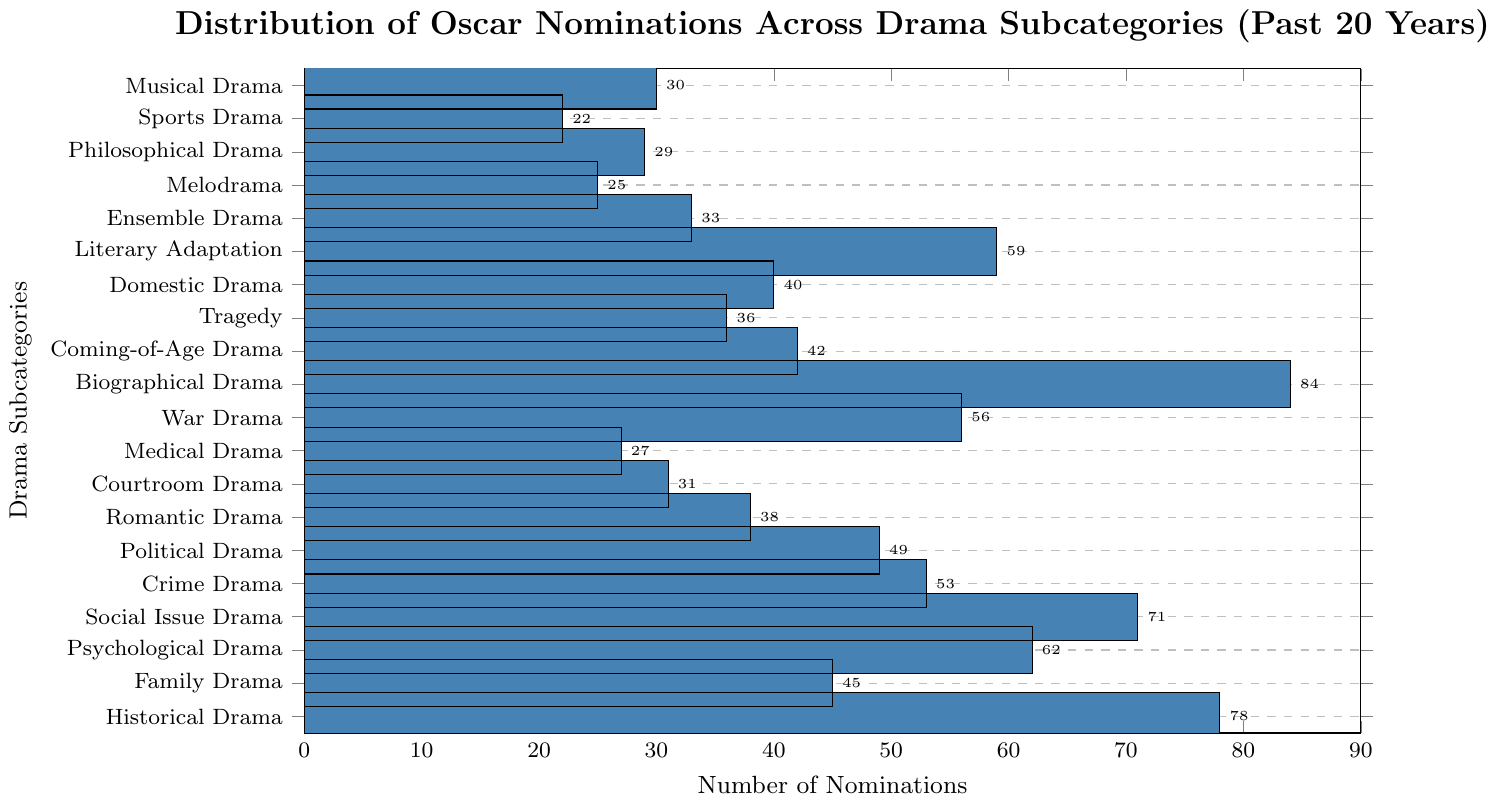What's the most nominated drama subcategory? Look for the subcategory with the longest bar in the chart. The Biographical Drama bar is the longest, indicating it has the highest number of nominations.
Answer: Biographical Drama How many more nominations does Historical Drama have compared to Family Drama? Locate the bars for Historical Drama and Family Drama. Historical Drama has 78 nominations, and Family Drama has 45. Subtract 45 from 78 to find the difference. 78 - 45 = 33
Answer: 33 Which subcategory has the least number of nominations? Look for the shortest bar in the figure. The Sports Drama bar is the shortest, indicating it has the fewest nominations.
Answer: Sports Drama What is the total number of nominations for Medical Drama, Crime Drama, and Literary Adaptation combined? Locate the bars for Medical Drama, Crime Drama, and Literary Adaptation. Medical Drama has 27 nominations, Crime Drama has 53, and Literary Adaptation has 59. Add these values to get the total: 27 + 53 + 59 = 139
Answer: 139 How many subcategories have more than 50 nominations? Count the number of bars where the nomination count exceeds 50. Historical Drama, Psychological Drama, Social Issue Drama, Biographical Drama, War Drama, Crime Drama, and Literary Adaptation all meet this criterion. There are 7 such subcategories.
Answer: 7 Which subcategory has a higher number of nominations: Tragedy or Domestic Drama? Compare the bars for Tragedy and Domestic Drama. Tragedy has 36 nominations, while Domestic Drama has 40. Domestic Drama has a higher number of nominations.
Answer: Domestic Drama What is the median number of nominations across all subcategories? List all the nomination counts, sort them in ascending order, and find the median (middle value). Ordered counts: 22, 25, 27, 29, 30, 31, 33, 36, 38, 40, 42, 45, 49, 53, 56, 59, 62, 71, 78, 84. The median of this ordered dataset (20 numbers) is the average of the 10th and 11th values: (40 + 42) / 2 = 41
Answer: 41 How many nominations do the three most nominated subcategories have in total? Identify the three subcategories with the longest bars: Biographical Drama (84), Historical Drama (78), and Social Issue Drama (71). Add these counts together: 84 + 78 + 71 = 233
Answer: 233 Is the number of nominations for Ensemble Drama greater than for Melodrama? Compare the heights of the Ensemble Drama and Melodrama bars. Ensemble Drama has 33 nominations, while Melodrama has 25. Ensemble Drama has more nominations.
Answer: Yes Which subcategory has exactly 49 nominations? Locate the bar that corresponds to 49 nominations by checking the length of bars and associated labels. Political Drama has exactly 49 nominations.
Answer: Political Drama 